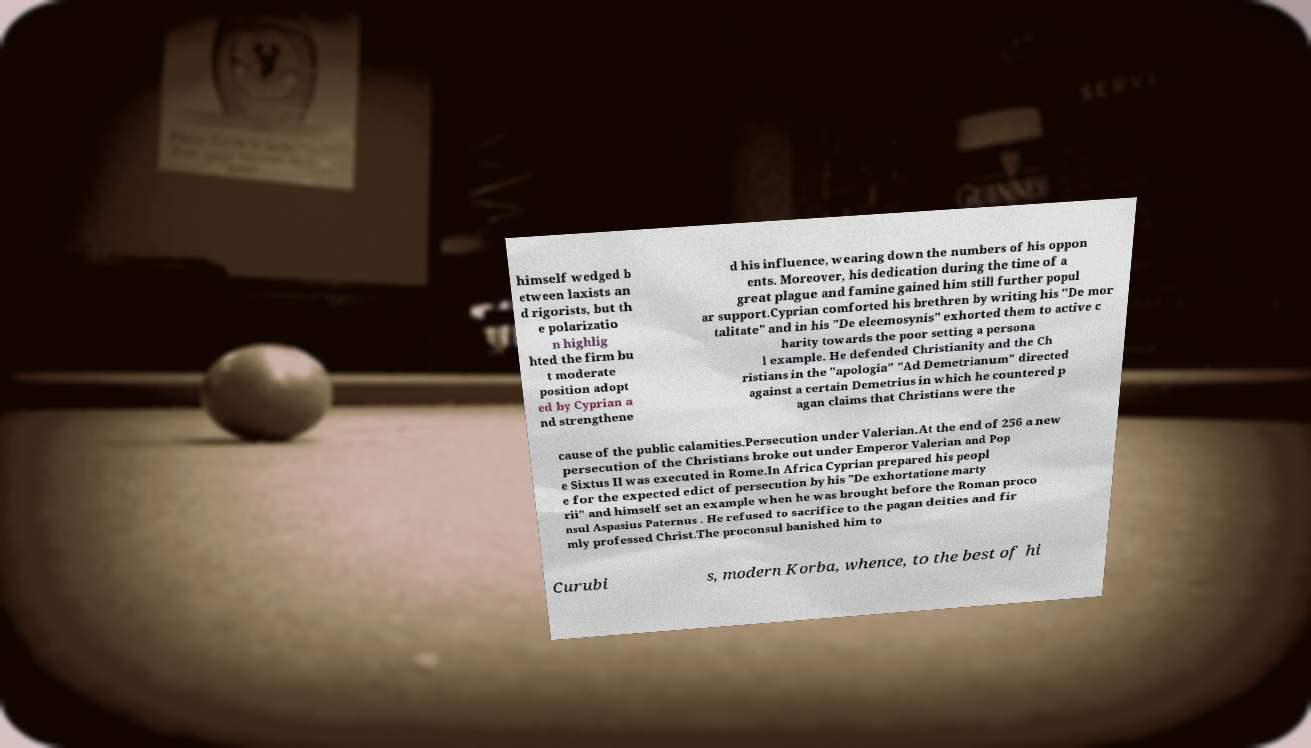For documentation purposes, I need the text within this image transcribed. Could you provide that? himself wedged b etween laxists an d rigorists, but th e polarizatio n highlig hted the firm bu t moderate position adopt ed by Cyprian a nd strengthene d his influence, wearing down the numbers of his oppon ents. Moreover, his dedication during the time of a great plague and famine gained him still further popul ar support.Cyprian comforted his brethren by writing his "De mor talitate" and in his "De eleemosynis" exhorted them to active c harity towards the poor setting a persona l example. He defended Christianity and the Ch ristians in the "apologia" "Ad Demetrianum" directed against a certain Demetrius in which he countered p agan claims that Christians were the cause of the public calamities.Persecution under Valerian.At the end of 256 a new persecution of the Christians broke out under Emperor Valerian and Pop e Sixtus II was executed in Rome.In Africa Cyprian prepared his peopl e for the expected edict of persecution by his "De exhortatione marty rii" and himself set an example when he was brought before the Roman proco nsul Aspasius Paternus . He refused to sacrifice to the pagan deities and fir mly professed Christ.The proconsul banished him to Curubi s, modern Korba, whence, to the best of hi 